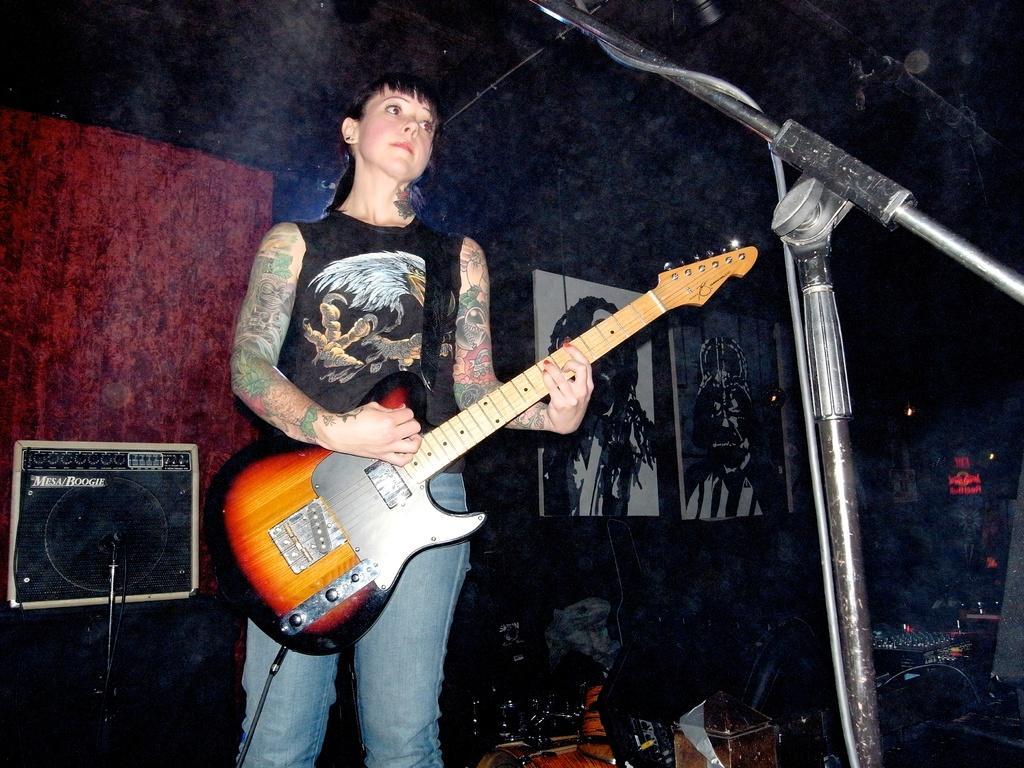Could you give a brief overview of what you see in this image? Here we can see a lady with a guitar in her hand probably playing the guitar and in front of her there is a microphone, the lady has tattoos on both hands and beside her there is a speaker 